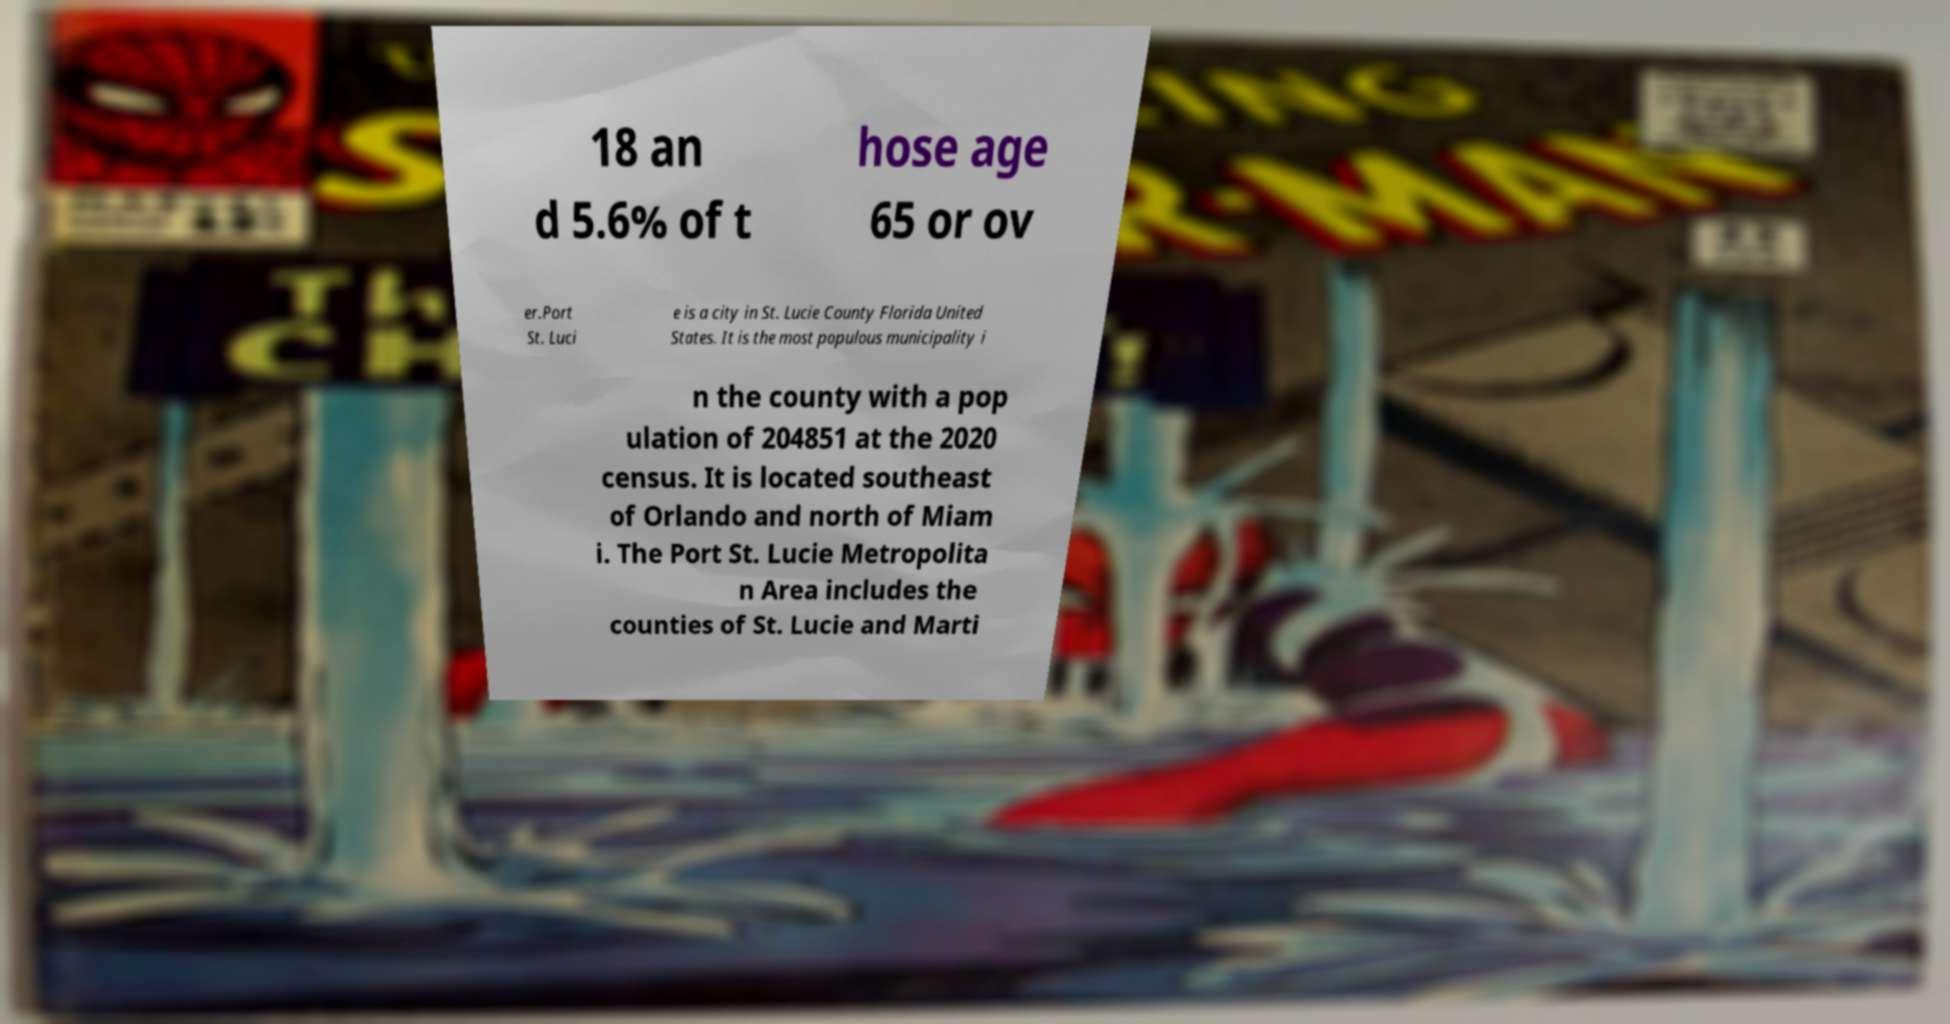Could you assist in decoding the text presented in this image and type it out clearly? 18 an d 5.6% of t hose age 65 or ov er.Port St. Luci e is a city in St. Lucie County Florida United States. It is the most populous municipality i n the county with a pop ulation of 204851 at the 2020 census. It is located southeast of Orlando and north of Miam i. The Port St. Lucie Metropolita n Area includes the counties of St. Lucie and Marti 